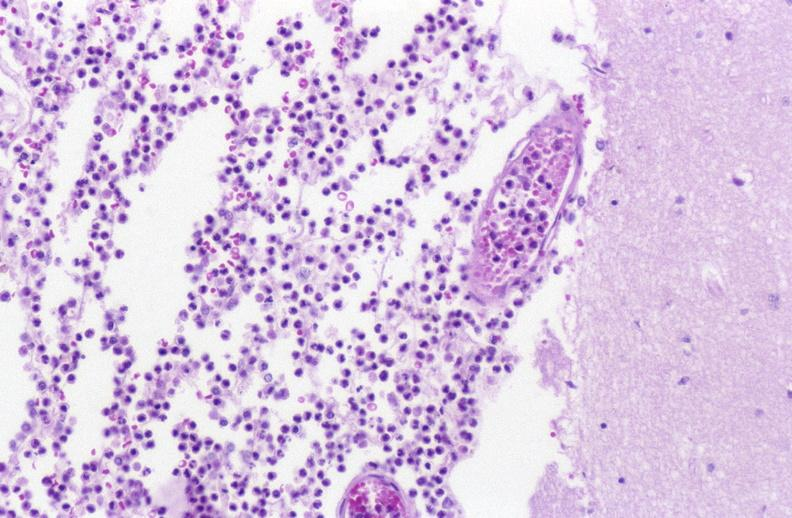s lymphangiomatosis generalized present?
Answer the question using a single word or phrase. No 